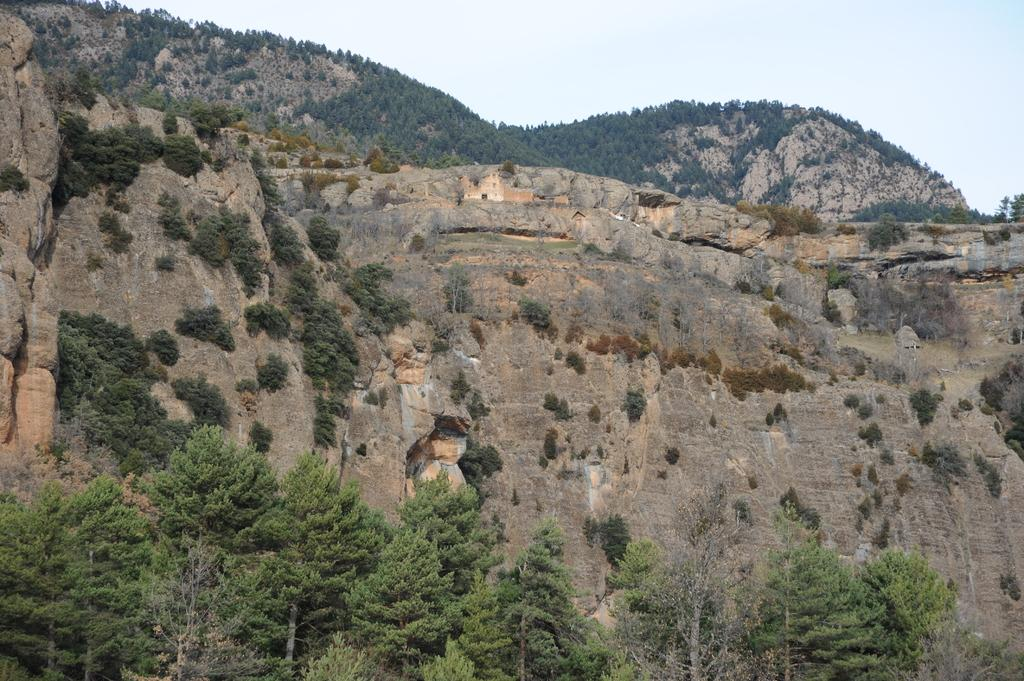What type of vegetation can be seen in the image? There are trees and plants in the image. What is visible in the background of the image? The sky is visible in the image. What type of natural landform can be seen in the image? There are mountains in the image. How long does it take for the jam to be made in the image? There is no jam present in the image, so it is not possible to determine how long it takes to make it. 